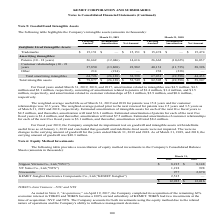From Kemet Corporation's financial document, Which years does the table provide information for the reconciliation of equity method investments to the Company's Consolidated Balance Sheets? The document shows two values: 2019 and 2018. From the document: "March 31, 2019 March 31, 2018 March 31, 2019 March 31, 2018..." Also, What was the amount of investments into Novasentis in 2019? According to the financial document, 977 (in thousands). The relevant text states: "Novasentis 977 2,870..." Also, What was the total investments in 2018? According to the financial document, 12,016 (in thousands). The relevant text states: "$ 12,925 $ 12,016..." Also, can you calculate: What was the change in the investments into Nippon Yttrium Co., Ltd ("NYC") between 2018 and 2019? Based on the calculation: 8,215-8,148, the result is 67 (in thousands). This is based on the information: "Nippon Yttrium Co., Ltd ("NYC") $ 8,215 $ 8,148 Nippon Yttrium Co., Ltd ("NYC") $ 8,215 $ 8,148..." The key data points involved are: 8,148, 8,215. Also, can you calculate: What was the change in the investments into Novasentis between 2018 and 2019? Based on the calculation: 977-2,870, the result is -1893 (in thousands). This is based on the information: "Novasentis 977 2,870 Novasentis 977 2,870..." The key data points involved are: 2,870, 977. Also, can you calculate: What was the percentage change in total investments between 2018 and 2019? To answer this question, I need to perform calculations using the financial data. The calculation is: (12,925-12,016)/12,016, which equals 7.56 (percentage). This is based on the information: "$ 12,925 $ 12,016 $ 12,925 $ 12,016..." The key data points involved are: 12,016, 12,925. 